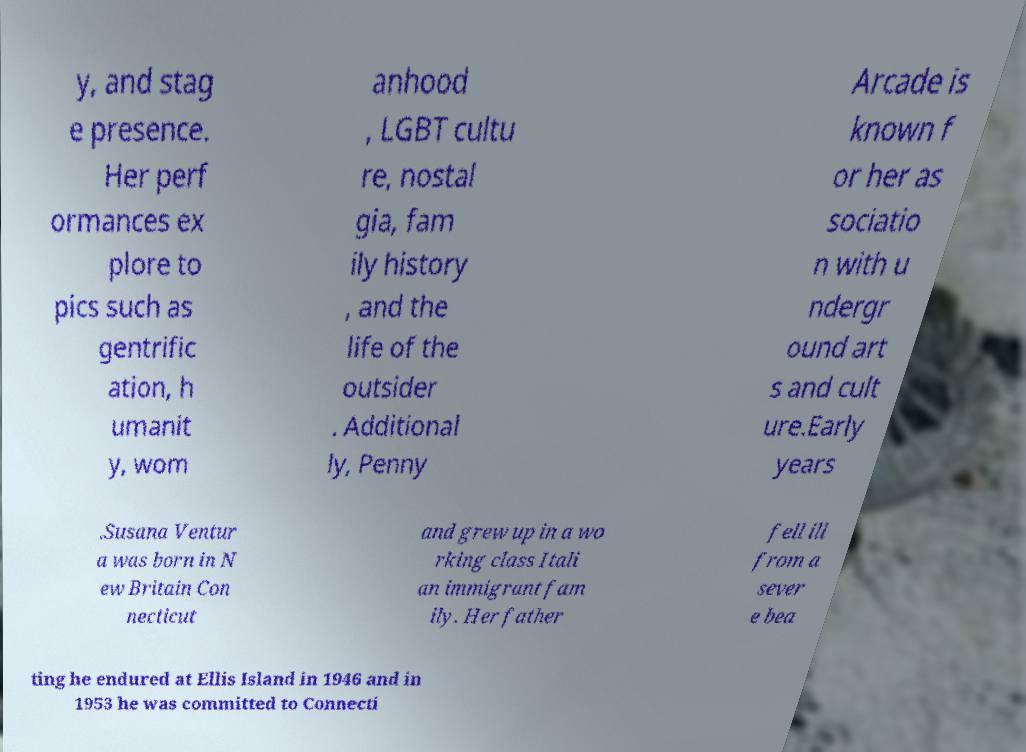Can you read and provide the text displayed in the image?This photo seems to have some interesting text. Can you extract and type it out for me? y, and stag e presence. Her perf ormances ex plore to pics such as gentrific ation, h umanit y, wom anhood , LGBT cultu re, nostal gia, fam ily history , and the life of the outsider . Additional ly, Penny Arcade is known f or her as sociatio n with u ndergr ound art s and cult ure.Early years .Susana Ventur a was born in N ew Britain Con necticut and grew up in a wo rking class Itali an immigrant fam ily. Her father fell ill from a sever e bea ting he endured at Ellis Island in 1946 and in 1953 he was committed to Connecti 